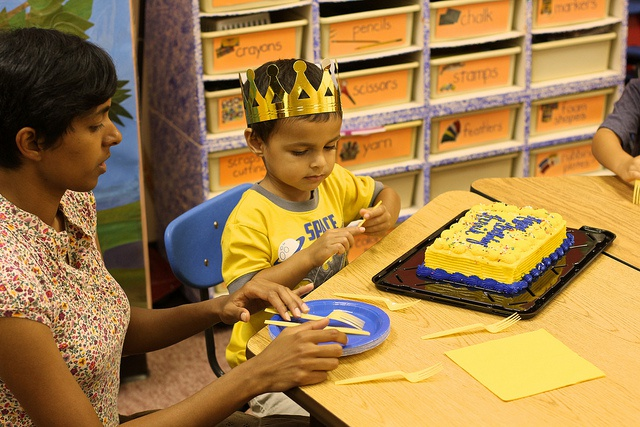Describe the objects in this image and their specific colors. I can see dining table in gray, gold, black, orange, and khaki tones, people in gray, black, olive, and maroon tones, people in gray, olive, orange, and gold tones, cake in gray, gold, orange, and black tones, and chair in gray, darkblue, blue, and black tones in this image. 